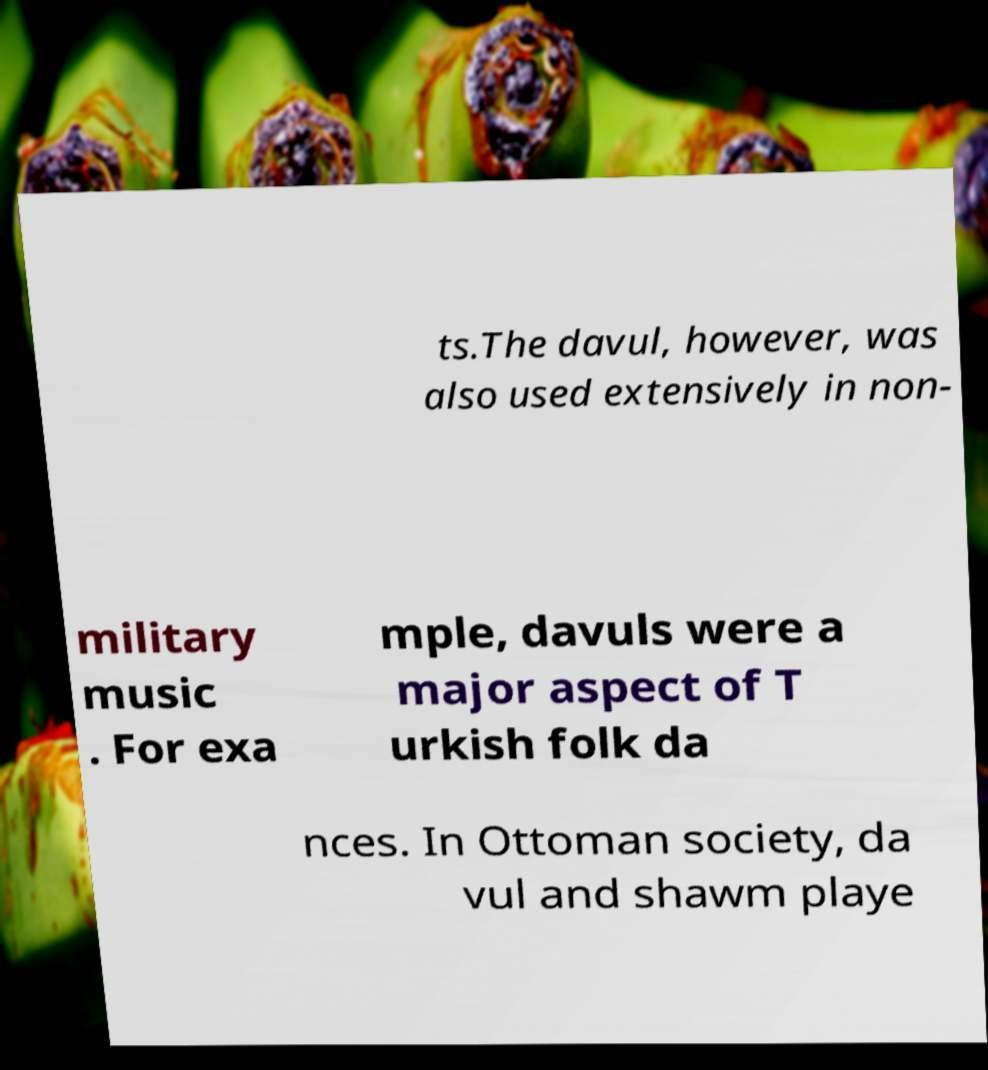Please read and relay the text visible in this image. What does it say? ts.The davul, however, was also used extensively in non- military music . For exa mple, davuls were a major aspect of T urkish folk da nces. In Ottoman society, da vul and shawm playe 